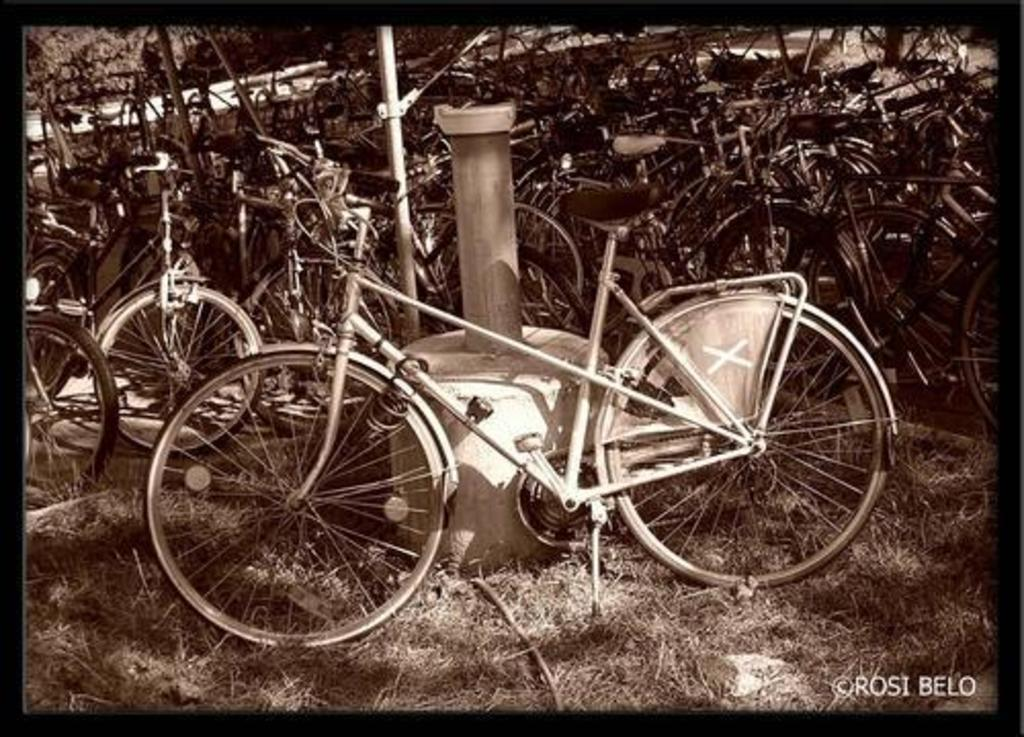What type of vehicles are present in the image? There are many bicycles in the image. What structures can be seen in the image? There are poles visible in the image. What type of vegetation is in the background of the image? There are trees in the background of the image. What type of ground surface is visible in the image? Grass is present on the ground in the image. What language is being spoken by the bicycles in the image? Bicycles do not speak any language, as they are inanimate objects. 